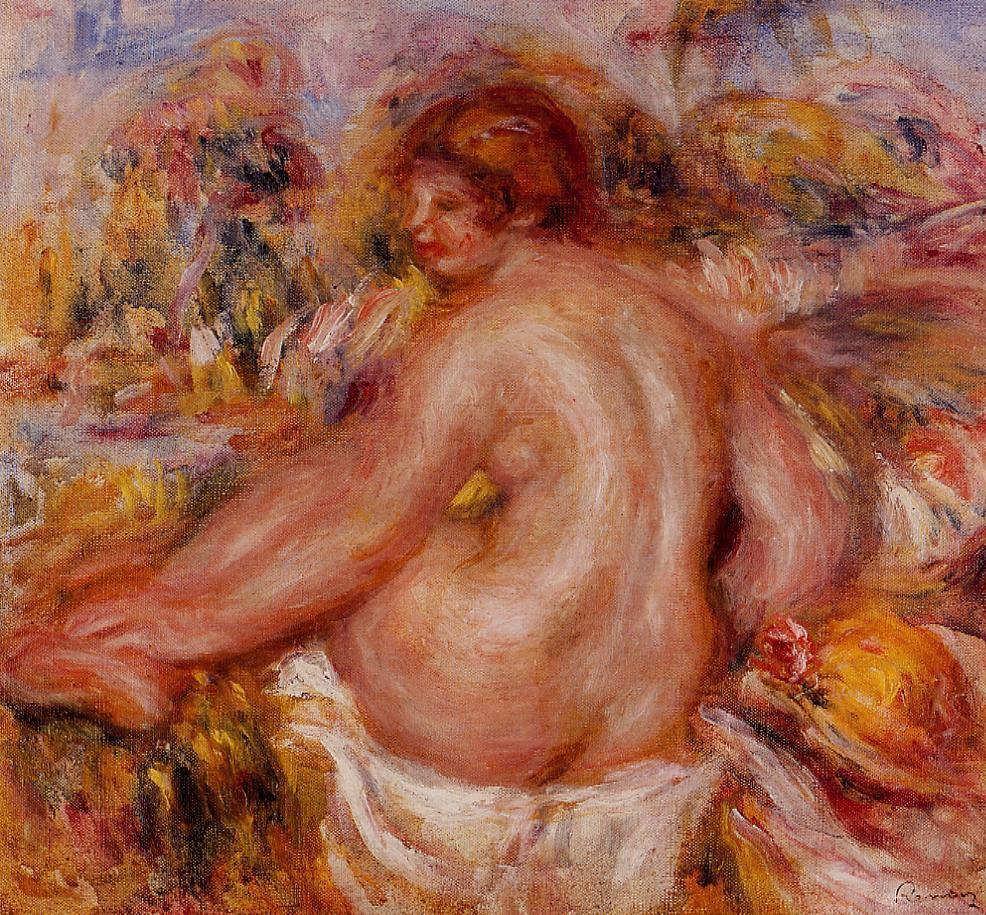Can you tell me more about the artist's techniques in this painting? Pierre-Auguste Renoir, a pivotal figure in the impressionist movement, employs several distinctive techniques in this painting to achieve its ethereal quality. Renoir's brushwork is loose and fluid, lending a sense of movement and spontaneity to the composition. His use of vibrant and warm color palettes, particularly his masterful orchestration of pinks, oranges, and yellows, imbues the scene with warmth and life.

Renoir's technique of layering thin washes of paint, known as 'glazing', creates a luminous effect that captures the subtle play of light on the woman's skin and the surrounding flowers. The soft, blurred background exemplifies the impressionist style’s focus on the ephemeral effects of light, rather than sharp, defined edges. This attention to light and color, along with his skillful blending of hues, allows Renoir to evoke a sense of depth and atmosphere, making the viewer feel as though they are witnessing a moment in time. His use of natural, flowing forms further enhances the organic and serene feel of the painting. What do you think this painting reveals about Renoir's perspective on beauty? Renoir's painting reveals his profound appreciation for natural beauty and the human form. The harmonious blending of the woman's body with the vibrant flora suggests a deep connection between humanity and nature. Renoir's choice to depict the nude figure with such grace and tranquility highlights his celebration of the pure and unadorned human body. His use of warm and inviting colors showcases his intention to evoke emotions of warmth, comfort, and serenity, indicating his belief in beauty as a source of joy and peace. Furthermore, the serene outdoor setting accentuated by soft, blurred edges symbolizes the transient and fleeting nature of beauty, making the viewer appreciate the ephemeral moments of life that Renoir so skillfully captures. 